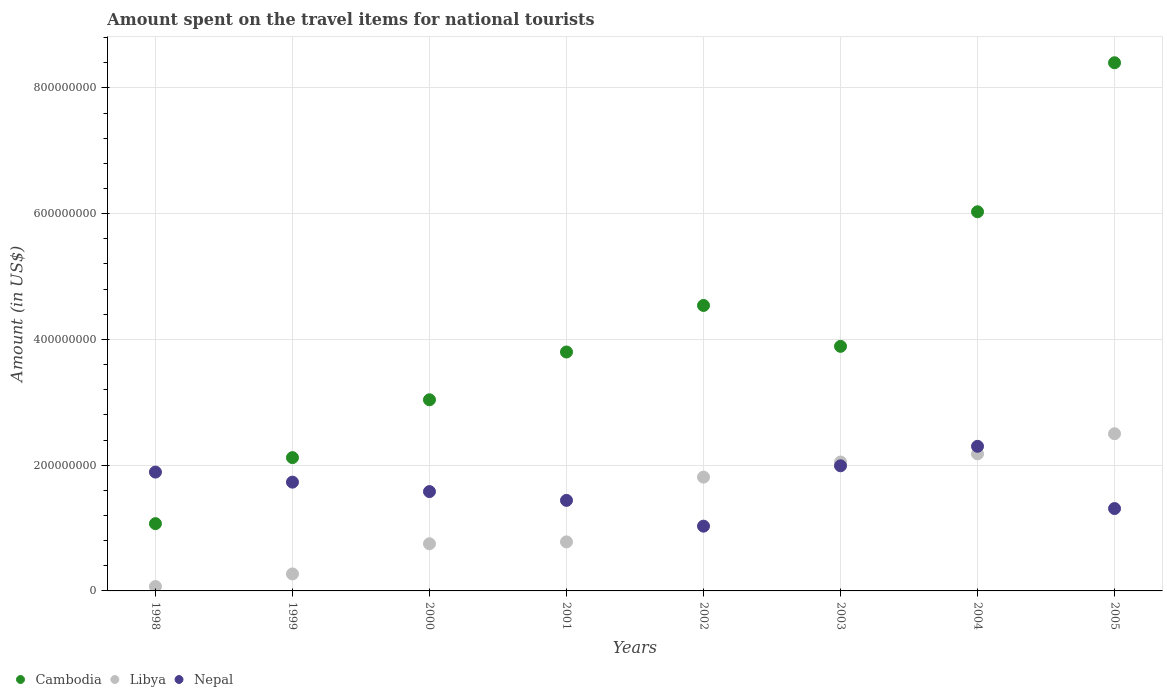What is the amount spent on the travel items for national tourists in Cambodia in 1998?
Your answer should be compact. 1.07e+08. Across all years, what is the maximum amount spent on the travel items for national tourists in Cambodia?
Your answer should be compact. 8.40e+08. Across all years, what is the minimum amount spent on the travel items for national tourists in Cambodia?
Provide a short and direct response. 1.07e+08. In which year was the amount spent on the travel items for national tourists in Nepal minimum?
Make the answer very short. 2002. What is the total amount spent on the travel items for national tourists in Libya in the graph?
Your response must be concise. 1.04e+09. What is the difference between the amount spent on the travel items for national tourists in Libya in 1998 and the amount spent on the travel items for national tourists in Nepal in 1999?
Keep it short and to the point. -1.66e+08. What is the average amount spent on the travel items for national tourists in Nepal per year?
Offer a terse response. 1.66e+08. In the year 1998, what is the difference between the amount spent on the travel items for national tourists in Nepal and amount spent on the travel items for national tourists in Libya?
Your response must be concise. 1.82e+08. What is the ratio of the amount spent on the travel items for national tourists in Libya in 2000 to that in 2003?
Make the answer very short. 0.37. What is the difference between the highest and the second highest amount spent on the travel items for national tourists in Nepal?
Keep it short and to the point. 3.10e+07. What is the difference between the highest and the lowest amount spent on the travel items for national tourists in Nepal?
Offer a very short reply. 1.27e+08. Is the sum of the amount spent on the travel items for national tourists in Libya in 1998 and 2000 greater than the maximum amount spent on the travel items for national tourists in Cambodia across all years?
Give a very brief answer. No. Is the amount spent on the travel items for national tourists in Libya strictly less than the amount spent on the travel items for national tourists in Cambodia over the years?
Keep it short and to the point. Yes. What is the difference between two consecutive major ticks on the Y-axis?
Your answer should be compact. 2.00e+08. Are the values on the major ticks of Y-axis written in scientific E-notation?
Make the answer very short. No. Does the graph contain grids?
Make the answer very short. Yes. Where does the legend appear in the graph?
Your answer should be very brief. Bottom left. What is the title of the graph?
Provide a succinct answer. Amount spent on the travel items for national tourists. What is the label or title of the Y-axis?
Make the answer very short. Amount (in US$). What is the Amount (in US$) of Cambodia in 1998?
Your answer should be compact. 1.07e+08. What is the Amount (in US$) in Nepal in 1998?
Your answer should be compact. 1.89e+08. What is the Amount (in US$) of Cambodia in 1999?
Provide a short and direct response. 2.12e+08. What is the Amount (in US$) of Libya in 1999?
Offer a very short reply. 2.70e+07. What is the Amount (in US$) of Nepal in 1999?
Keep it short and to the point. 1.73e+08. What is the Amount (in US$) of Cambodia in 2000?
Your answer should be very brief. 3.04e+08. What is the Amount (in US$) of Libya in 2000?
Keep it short and to the point. 7.50e+07. What is the Amount (in US$) in Nepal in 2000?
Offer a terse response. 1.58e+08. What is the Amount (in US$) of Cambodia in 2001?
Make the answer very short. 3.80e+08. What is the Amount (in US$) of Libya in 2001?
Provide a succinct answer. 7.80e+07. What is the Amount (in US$) of Nepal in 2001?
Your response must be concise. 1.44e+08. What is the Amount (in US$) of Cambodia in 2002?
Offer a very short reply. 4.54e+08. What is the Amount (in US$) of Libya in 2002?
Ensure brevity in your answer.  1.81e+08. What is the Amount (in US$) of Nepal in 2002?
Provide a short and direct response. 1.03e+08. What is the Amount (in US$) of Cambodia in 2003?
Provide a short and direct response. 3.89e+08. What is the Amount (in US$) in Libya in 2003?
Your answer should be compact. 2.05e+08. What is the Amount (in US$) of Nepal in 2003?
Keep it short and to the point. 1.99e+08. What is the Amount (in US$) in Cambodia in 2004?
Your answer should be very brief. 6.03e+08. What is the Amount (in US$) in Libya in 2004?
Offer a terse response. 2.18e+08. What is the Amount (in US$) in Nepal in 2004?
Make the answer very short. 2.30e+08. What is the Amount (in US$) in Cambodia in 2005?
Offer a terse response. 8.40e+08. What is the Amount (in US$) in Libya in 2005?
Give a very brief answer. 2.50e+08. What is the Amount (in US$) of Nepal in 2005?
Offer a terse response. 1.31e+08. Across all years, what is the maximum Amount (in US$) in Cambodia?
Give a very brief answer. 8.40e+08. Across all years, what is the maximum Amount (in US$) of Libya?
Your answer should be compact. 2.50e+08. Across all years, what is the maximum Amount (in US$) of Nepal?
Make the answer very short. 2.30e+08. Across all years, what is the minimum Amount (in US$) of Cambodia?
Your answer should be compact. 1.07e+08. Across all years, what is the minimum Amount (in US$) in Nepal?
Your answer should be compact. 1.03e+08. What is the total Amount (in US$) of Cambodia in the graph?
Provide a short and direct response. 3.29e+09. What is the total Amount (in US$) of Libya in the graph?
Provide a succinct answer. 1.04e+09. What is the total Amount (in US$) in Nepal in the graph?
Your answer should be compact. 1.33e+09. What is the difference between the Amount (in US$) in Cambodia in 1998 and that in 1999?
Provide a succinct answer. -1.05e+08. What is the difference between the Amount (in US$) in Libya in 1998 and that in 1999?
Offer a terse response. -2.00e+07. What is the difference between the Amount (in US$) in Nepal in 1998 and that in 1999?
Your answer should be compact. 1.60e+07. What is the difference between the Amount (in US$) of Cambodia in 1998 and that in 2000?
Offer a terse response. -1.97e+08. What is the difference between the Amount (in US$) of Libya in 1998 and that in 2000?
Provide a succinct answer. -6.80e+07. What is the difference between the Amount (in US$) of Nepal in 1998 and that in 2000?
Make the answer very short. 3.10e+07. What is the difference between the Amount (in US$) in Cambodia in 1998 and that in 2001?
Your answer should be very brief. -2.73e+08. What is the difference between the Amount (in US$) in Libya in 1998 and that in 2001?
Your response must be concise. -7.10e+07. What is the difference between the Amount (in US$) in Nepal in 1998 and that in 2001?
Offer a terse response. 4.50e+07. What is the difference between the Amount (in US$) in Cambodia in 1998 and that in 2002?
Ensure brevity in your answer.  -3.47e+08. What is the difference between the Amount (in US$) of Libya in 1998 and that in 2002?
Provide a succinct answer. -1.74e+08. What is the difference between the Amount (in US$) of Nepal in 1998 and that in 2002?
Give a very brief answer. 8.60e+07. What is the difference between the Amount (in US$) in Cambodia in 1998 and that in 2003?
Ensure brevity in your answer.  -2.82e+08. What is the difference between the Amount (in US$) of Libya in 1998 and that in 2003?
Keep it short and to the point. -1.98e+08. What is the difference between the Amount (in US$) of Nepal in 1998 and that in 2003?
Your response must be concise. -1.00e+07. What is the difference between the Amount (in US$) of Cambodia in 1998 and that in 2004?
Your answer should be very brief. -4.96e+08. What is the difference between the Amount (in US$) of Libya in 1998 and that in 2004?
Provide a short and direct response. -2.11e+08. What is the difference between the Amount (in US$) in Nepal in 1998 and that in 2004?
Ensure brevity in your answer.  -4.10e+07. What is the difference between the Amount (in US$) of Cambodia in 1998 and that in 2005?
Your answer should be compact. -7.33e+08. What is the difference between the Amount (in US$) of Libya in 1998 and that in 2005?
Offer a very short reply. -2.43e+08. What is the difference between the Amount (in US$) in Nepal in 1998 and that in 2005?
Ensure brevity in your answer.  5.80e+07. What is the difference between the Amount (in US$) of Cambodia in 1999 and that in 2000?
Offer a terse response. -9.20e+07. What is the difference between the Amount (in US$) in Libya in 1999 and that in 2000?
Provide a short and direct response. -4.80e+07. What is the difference between the Amount (in US$) of Nepal in 1999 and that in 2000?
Your response must be concise. 1.50e+07. What is the difference between the Amount (in US$) in Cambodia in 1999 and that in 2001?
Provide a succinct answer. -1.68e+08. What is the difference between the Amount (in US$) of Libya in 1999 and that in 2001?
Keep it short and to the point. -5.10e+07. What is the difference between the Amount (in US$) in Nepal in 1999 and that in 2001?
Your answer should be compact. 2.90e+07. What is the difference between the Amount (in US$) in Cambodia in 1999 and that in 2002?
Make the answer very short. -2.42e+08. What is the difference between the Amount (in US$) in Libya in 1999 and that in 2002?
Your answer should be compact. -1.54e+08. What is the difference between the Amount (in US$) of Nepal in 1999 and that in 2002?
Offer a terse response. 7.00e+07. What is the difference between the Amount (in US$) in Cambodia in 1999 and that in 2003?
Provide a short and direct response. -1.77e+08. What is the difference between the Amount (in US$) of Libya in 1999 and that in 2003?
Offer a very short reply. -1.78e+08. What is the difference between the Amount (in US$) in Nepal in 1999 and that in 2003?
Your answer should be very brief. -2.60e+07. What is the difference between the Amount (in US$) of Cambodia in 1999 and that in 2004?
Your answer should be compact. -3.91e+08. What is the difference between the Amount (in US$) in Libya in 1999 and that in 2004?
Offer a terse response. -1.91e+08. What is the difference between the Amount (in US$) in Nepal in 1999 and that in 2004?
Keep it short and to the point. -5.70e+07. What is the difference between the Amount (in US$) in Cambodia in 1999 and that in 2005?
Provide a succinct answer. -6.28e+08. What is the difference between the Amount (in US$) in Libya in 1999 and that in 2005?
Keep it short and to the point. -2.23e+08. What is the difference between the Amount (in US$) in Nepal in 1999 and that in 2005?
Offer a terse response. 4.20e+07. What is the difference between the Amount (in US$) of Cambodia in 2000 and that in 2001?
Your answer should be very brief. -7.60e+07. What is the difference between the Amount (in US$) of Libya in 2000 and that in 2001?
Offer a terse response. -3.00e+06. What is the difference between the Amount (in US$) of Nepal in 2000 and that in 2001?
Your response must be concise. 1.40e+07. What is the difference between the Amount (in US$) in Cambodia in 2000 and that in 2002?
Make the answer very short. -1.50e+08. What is the difference between the Amount (in US$) in Libya in 2000 and that in 2002?
Your response must be concise. -1.06e+08. What is the difference between the Amount (in US$) in Nepal in 2000 and that in 2002?
Your answer should be compact. 5.50e+07. What is the difference between the Amount (in US$) in Cambodia in 2000 and that in 2003?
Keep it short and to the point. -8.50e+07. What is the difference between the Amount (in US$) in Libya in 2000 and that in 2003?
Give a very brief answer. -1.30e+08. What is the difference between the Amount (in US$) in Nepal in 2000 and that in 2003?
Your response must be concise. -4.10e+07. What is the difference between the Amount (in US$) in Cambodia in 2000 and that in 2004?
Ensure brevity in your answer.  -2.99e+08. What is the difference between the Amount (in US$) of Libya in 2000 and that in 2004?
Offer a terse response. -1.43e+08. What is the difference between the Amount (in US$) of Nepal in 2000 and that in 2004?
Give a very brief answer. -7.20e+07. What is the difference between the Amount (in US$) of Cambodia in 2000 and that in 2005?
Make the answer very short. -5.36e+08. What is the difference between the Amount (in US$) of Libya in 2000 and that in 2005?
Your answer should be very brief. -1.75e+08. What is the difference between the Amount (in US$) in Nepal in 2000 and that in 2005?
Your response must be concise. 2.70e+07. What is the difference between the Amount (in US$) of Cambodia in 2001 and that in 2002?
Offer a terse response. -7.40e+07. What is the difference between the Amount (in US$) in Libya in 2001 and that in 2002?
Provide a succinct answer. -1.03e+08. What is the difference between the Amount (in US$) in Nepal in 2001 and that in 2002?
Your answer should be compact. 4.10e+07. What is the difference between the Amount (in US$) in Cambodia in 2001 and that in 2003?
Give a very brief answer. -9.00e+06. What is the difference between the Amount (in US$) of Libya in 2001 and that in 2003?
Provide a short and direct response. -1.27e+08. What is the difference between the Amount (in US$) in Nepal in 2001 and that in 2003?
Provide a succinct answer. -5.50e+07. What is the difference between the Amount (in US$) of Cambodia in 2001 and that in 2004?
Offer a terse response. -2.23e+08. What is the difference between the Amount (in US$) in Libya in 2001 and that in 2004?
Make the answer very short. -1.40e+08. What is the difference between the Amount (in US$) of Nepal in 2001 and that in 2004?
Your response must be concise. -8.60e+07. What is the difference between the Amount (in US$) of Cambodia in 2001 and that in 2005?
Your answer should be compact. -4.60e+08. What is the difference between the Amount (in US$) in Libya in 2001 and that in 2005?
Your answer should be compact. -1.72e+08. What is the difference between the Amount (in US$) of Nepal in 2001 and that in 2005?
Offer a very short reply. 1.30e+07. What is the difference between the Amount (in US$) of Cambodia in 2002 and that in 2003?
Offer a very short reply. 6.50e+07. What is the difference between the Amount (in US$) in Libya in 2002 and that in 2003?
Keep it short and to the point. -2.40e+07. What is the difference between the Amount (in US$) in Nepal in 2002 and that in 2003?
Ensure brevity in your answer.  -9.60e+07. What is the difference between the Amount (in US$) in Cambodia in 2002 and that in 2004?
Offer a very short reply. -1.49e+08. What is the difference between the Amount (in US$) in Libya in 2002 and that in 2004?
Your answer should be compact. -3.70e+07. What is the difference between the Amount (in US$) of Nepal in 2002 and that in 2004?
Keep it short and to the point. -1.27e+08. What is the difference between the Amount (in US$) of Cambodia in 2002 and that in 2005?
Make the answer very short. -3.86e+08. What is the difference between the Amount (in US$) in Libya in 2002 and that in 2005?
Keep it short and to the point. -6.90e+07. What is the difference between the Amount (in US$) in Nepal in 2002 and that in 2005?
Offer a very short reply. -2.80e+07. What is the difference between the Amount (in US$) of Cambodia in 2003 and that in 2004?
Give a very brief answer. -2.14e+08. What is the difference between the Amount (in US$) of Libya in 2003 and that in 2004?
Keep it short and to the point. -1.30e+07. What is the difference between the Amount (in US$) in Nepal in 2003 and that in 2004?
Make the answer very short. -3.10e+07. What is the difference between the Amount (in US$) in Cambodia in 2003 and that in 2005?
Keep it short and to the point. -4.51e+08. What is the difference between the Amount (in US$) in Libya in 2003 and that in 2005?
Provide a succinct answer. -4.50e+07. What is the difference between the Amount (in US$) in Nepal in 2003 and that in 2005?
Your answer should be very brief. 6.80e+07. What is the difference between the Amount (in US$) of Cambodia in 2004 and that in 2005?
Offer a very short reply. -2.37e+08. What is the difference between the Amount (in US$) in Libya in 2004 and that in 2005?
Provide a short and direct response. -3.20e+07. What is the difference between the Amount (in US$) of Nepal in 2004 and that in 2005?
Provide a short and direct response. 9.90e+07. What is the difference between the Amount (in US$) of Cambodia in 1998 and the Amount (in US$) of Libya in 1999?
Keep it short and to the point. 8.00e+07. What is the difference between the Amount (in US$) of Cambodia in 1998 and the Amount (in US$) of Nepal in 1999?
Offer a very short reply. -6.60e+07. What is the difference between the Amount (in US$) of Libya in 1998 and the Amount (in US$) of Nepal in 1999?
Offer a terse response. -1.66e+08. What is the difference between the Amount (in US$) in Cambodia in 1998 and the Amount (in US$) in Libya in 2000?
Provide a succinct answer. 3.20e+07. What is the difference between the Amount (in US$) in Cambodia in 1998 and the Amount (in US$) in Nepal in 2000?
Provide a succinct answer. -5.10e+07. What is the difference between the Amount (in US$) of Libya in 1998 and the Amount (in US$) of Nepal in 2000?
Offer a terse response. -1.51e+08. What is the difference between the Amount (in US$) in Cambodia in 1998 and the Amount (in US$) in Libya in 2001?
Your answer should be compact. 2.90e+07. What is the difference between the Amount (in US$) in Cambodia in 1998 and the Amount (in US$) in Nepal in 2001?
Provide a short and direct response. -3.70e+07. What is the difference between the Amount (in US$) in Libya in 1998 and the Amount (in US$) in Nepal in 2001?
Your answer should be compact. -1.37e+08. What is the difference between the Amount (in US$) in Cambodia in 1998 and the Amount (in US$) in Libya in 2002?
Ensure brevity in your answer.  -7.40e+07. What is the difference between the Amount (in US$) in Libya in 1998 and the Amount (in US$) in Nepal in 2002?
Your response must be concise. -9.60e+07. What is the difference between the Amount (in US$) of Cambodia in 1998 and the Amount (in US$) of Libya in 2003?
Ensure brevity in your answer.  -9.80e+07. What is the difference between the Amount (in US$) of Cambodia in 1998 and the Amount (in US$) of Nepal in 2003?
Give a very brief answer. -9.20e+07. What is the difference between the Amount (in US$) of Libya in 1998 and the Amount (in US$) of Nepal in 2003?
Make the answer very short. -1.92e+08. What is the difference between the Amount (in US$) in Cambodia in 1998 and the Amount (in US$) in Libya in 2004?
Provide a succinct answer. -1.11e+08. What is the difference between the Amount (in US$) in Cambodia in 1998 and the Amount (in US$) in Nepal in 2004?
Ensure brevity in your answer.  -1.23e+08. What is the difference between the Amount (in US$) in Libya in 1998 and the Amount (in US$) in Nepal in 2004?
Offer a terse response. -2.23e+08. What is the difference between the Amount (in US$) in Cambodia in 1998 and the Amount (in US$) in Libya in 2005?
Provide a short and direct response. -1.43e+08. What is the difference between the Amount (in US$) of Cambodia in 1998 and the Amount (in US$) of Nepal in 2005?
Make the answer very short. -2.40e+07. What is the difference between the Amount (in US$) of Libya in 1998 and the Amount (in US$) of Nepal in 2005?
Offer a terse response. -1.24e+08. What is the difference between the Amount (in US$) in Cambodia in 1999 and the Amount (in US$) in Libya in 2000?
Offer a very short reply. 1.37e+08. What is the difference between the Amount (in US$) in Cambodia in 1999 and the Amount (in US$) in Nepal in 2000?
Offer a terse response. 5.40e+07. What is the difference between the Amount (in US$) in Libya in 1999 and the Amount (in US$) in Nepal in 2000?
Give a very brief answer. -1.31e+08. What is the difference between the Amount (in US$) in Cambodia in 1999 and the Amount (in US$) in Libya in 2001?
Provide a succinct answer. 1.34e+08. What is the difference between the Amount (in US$) of Cambodia in 1999 and the Amount (in US$) of Nepal in 2001?
Your response must be concise. 6.80e+07. What is the difference between the Amount (in US$) in Libya in 1999 and the Amount (in US$) in Nepal in 2001?
Offer a very short reply. -1.17e+08. What is the difference between the Amount (in US$) of Cambodia in 1999 and the Amount (in US$) of Libya in 2002?
Make the answer very short. 3.10e+07. What is the difference between the Amount (in US$) in Cambodia in 1999 and the Amount (in US$) in Nepal in 2002?
Your answer should be compact. 1.09e+08. What is the difference between the Amount (in US$) of Libya in 1999 and the Amount (in US$) of Nepal in 2002?
Keep it short and to the point. -7.60e+07. What is the difference between the Amount (in US$) of Cambodia in 1999 and the Amount (in US$) of Nepal in 2003?
Offer a terse response. 1.30e+07. What is the difference between the Amount (in US$) in Libya in 1999 and the Amount (in US$) in Nepal in 2003?
Keep it short and to the point. -1.72e+08. What is the difference between the Amount (in US$) in Cambodia in 1999 and the Amount (in US$) in Libya in 2004?
Provide a short and direct response. -6.00e+06. What is the difference between the Amount (in US$) in Cambodia in 1999 and the Amount (in US$) in Nepal in 2004?
Give a very brief answer. -1.80e+07. What is the difference between the Amount (in US$) in Libya in 1999 and the Amount (in US$) in Nepal in 2004?
Make the answer very short. -2.03e+08. What is the difference between the Amount (in US$) in Cambodia in 1999 and the Amount (in US$) in Libya in 2005?
Your answer should be very brief. -3.80e+07. What is the difference between the Amount (in US$) in Cambodia in 1999 and the Amount (in US$) in Nepal in 2005?
Provide a short and direct response. 8.10e+07. What is the difference between the Amount (in US$) in Libya in 1999 and the Amount (in US$) in Nepal in 2005?
Your answer should be very brief. -1.04e+08. What is the difference between the Amount (in US$) of Cambodia in 2000 and the Amount (in US$) of Libya in 2001?
Make the answer very short. 2.26e+08. What is the difference between the Amount (in US$) in Cambodia in 2000 and the Amount (in US$) in Nepal in 2001?
Provide a succinct answer. 1.60e+08. What is the difference between the Amount (in US$) of Libya in 2000 and the Amount (in US$) of Nepal in 2001?
Ensure brevity in your answer.  -6.90e+07. What is the difference between the Amount (in US$) in Cambodia in 2000 and the Amount (in US$) in Libya in 2002?
Your answer should be compact. 1.23e+08. What is the difference between the Amount (in US$) in Cambodia in 2000 and the Amount (in US$) in Nepal in 2002?
Your answer should be very brief. 2.01e+08. What is the difference between the Amount (in US$) of Libya in 2000 and the Amount (in US$) of Nepal in 2002?
Make the answer very short. -2.80e+07. What is the difference between the Amount (in US$) in Cambodia in 2000 and the Amount (in US$) in Libya in 2003?
Your answer should be very brief. 9.90e+07. What is the difference between the Amount (in US$) of Cambodia in 2000 and the Amount (in US$) of Nepal in 2003?
Your response must be concise. 1.05e+08. What is the difference between the Amount (in US$) in Libya in 2000 and the Amount (in US$) in Nepal in 2003?
Offer a very short reply. -1.24e+08. What is the difference between the Amount (in US$) of Cambodia in 2000 and the Amount (in US$) of Libya in 2004?
Your answer should be compact. 8.60e+07. What is the difference between the Amount (in US$) in Cambodia in 2000 and the Amount (in US$) in Nepal in 2004?
Your answer should be very brief. 7.40e+07. What is the difference between the Amount (in US$) in Libya in 2000 and the Amount (in US$) in Nepal in 2004?
Your response must be concise. -1.55e+08. What is the difference between the Amount (in US$) of Cambodia in 2000 and the Amount (in US$) of Libya in 2005?
Give a very brief answer. 5.40e+07. What is the difference between the Amount (in US$) in Cambodia in 2000 and the Amount (in US$) in Nepal in 2005?
Make the answer very short. 1.73e+08. What is the difference between the Amount (in US$) in Libya in 2000 and the Amount (in US$) in Nepal in 2005?
Provide a succinct answer. -5.60e+07. What is the difference between the Amount (in US$) of Cambodia in 2001 and the Amount (in US$) of Libya in 2002?
Provide a succinct answer. 1.99e+08. What is the difference between the Amount (in US$) in Cambodia in 2001 and the Amount (in US$) in Nepal in 2002?
Provide a succinct answer. 2.77e+08. What is the difference between the Amount (in US$) of Libya in 2001 and the Amount (in US$) of Nepal in 2002?
Provide a succinct answer. -2.50e+07. What is the difference between the Amount (in US$) in Cambodia in 2001 and the Amount (in US$) in Libya in 2003?
Offer a very short reply. 1.75e+08. What is the difference between the Amount (in US$) of Cambodia in 2001 and the Amount (in US$) of Nepal in 2003?
Provide a succinct answer. 1.81e+08. What is the difference between the Amount (in US$) in Libya in 2001 and the Amount (in US$) in Nepal in 2003?
Ensure brevity in your answer.  -1.21e+08. What is the difference between the Amount (in US$) of Cambodia in 2001 and the Amount (in US$) of Libya in 2004?
Ensure brevity in your answer.  1.62e+08. What is the difference between the Amount (in US$) of Cambodia in 2001 and the Amount (in US$) of Nepal in 2004?
Offer a very short reply. 1.50e+08. What is the difference between the Amount (in US$) in Libya in 2001 and the Amount (in US$) in Nepal in 2004?
Provide a short and direct response. -1.52e+08. What is the difference between the Amount (in US$) in Cambodia in 2001 and the Amount (in US$) in Libya in 2005?
Ensure brevity in your answer.  1.30e+08. What is the difference between the Amount (in US$) in Cambodia in 2001 and the Amount (in US$) in Nepal in 2005?
Your answer should be very brief. 2.49e+08. What is the difference between the Amount (in US$) in Libya in 2001 and the Amount (in US$) in Nepal in 2005?
Make the answer very short. -5.30e+07. What is the difference between the Amount (in US$) of Cambodia in 2002 and the Amount (in US$) of Libya in 2003?
Offer a very short reply. 2.49e+08. What is the difference between the Amount (in US$) in Cambodia in 2002 and the Amount (in US$) in Nepal in 2003?
Give a very brief answer. 2.55e+08. What is the difference between the Amount (in US$) of Libya in 2002 and the Amount (in US$) of Nepal in 2003?
Your answer should be compact. -1.80e+07. What is the difference between the Amount (in US$) in Cambodia in 2002 and the Amount (in US$) in Libya in 2004?
Ensure brevity in your answer.  2.36e+08. What is the difference between the Amount (in US$) of Cambodia in 2002 and the Amount (in US$) of Nepal in 2004?
Your response must be concise. 2.24e+08. What is the difference between the Amount (in US$) of Libya in 2002 and the Amount (in US$) of Nepal in 2004?
Offer a terse response. -4.90e+07. What is the difference between the Amount (in US$) in Cambodia in 2002 and the Amount (in US$) in Libya in 2005?
Your response must be concise. 2.04e+08. What is the difference between the Amount (in US$) of Cambodia in 2002 and the Amount (in US$) of Nepal in 2005?
Offer a very short reply. 3.23e+08. What is the difference between the Amount (in US$) in Cambodia in 2003 and the Amount (in US$) in Libya in 2004?
Offer a very short reply. 1.71e+08. What is the difference between the Amount (in US$) in Cambodia in 2003 and the Amount (in US$) in Nepal in 2004?
Offer a terse response. 1.59e+08. What is the difference between the Amount (in US$) in Libya in 2003 and the Amount (in US$) in Nepal in 2004?
Your response must be concise. -2.50e+07. What is the difference between the Amount (in US$) of Cambodia in 2003 and the Amount (in US$) of Libya in 2005?
Make the answer very short. 1.39e+08. What is the difference between the Amount (in US$) of Cambodia in 2003 and the Amount (in US$) of Nepal in 2005?
Ensure brevity in your answer.  2.58e+08. What is the difference between the Amount (in US$) of Libya in 2003 and the Amount (in US$) of Nepal in 2005?
Give a very brief answer. 7.40e+07. What is the difference between the Amount (in US$) in Cambodia in 2004 and the Amount (in US$) in Libya in 2005?
Your answer should be very brief. 3.53e+08. What is the difference between the Amount (in US$) of Cambodia in 2004 and the Amount (in US$) of Nepal in 2005?
Your answer should be very brief. 4.72e+08. What is the difference between the Amount (in US$) in Libya in 2004 and the Amount (in US$) in Nepal in 2005?
Provide a succinct answer. 8.70e+07. What is the average Amount (in US$) in Cambodia per year?
Your response must be concise. 4.11e+08. What is the average Amount (in US$) of Libya per year?
Give a very brief answer. 1.30e+08. What is the average Amount (in US$) of Nepal per year?
Your answer should be very brief. 1.66e+08. In the year 1998, what is the difference between the Amount (in US$) in Cambodia and Amount (in US$) in Libya?
Ensure brevity in your answer.  1.00e+08. In the year 1998, what is the difference between the Amount (in US$) of Cambodia and Amount (in US$) of Nepal?
Make the answer very short. -8.20e+07. In the year 1998, what is the difference between the Amount (in US$) of Libya and Amount (in US$) of Nepal?
Offer a very short reply. -1.82e+08. In the year 1999, what is the difference between the Amount (in US$) in Cambodia and Amount (in US$) in Libya?
Keep it short and to the point. 1.85e+08. In the year 1999, what is the difference between the Amount (in US$) of Cambodia and Amount (in US$) of Nepal?
Provide a succinct answer. 3.90e+07. In the year 1999, what is the difference between the Amount (in US$) of Libya and Amount (in US$) of Nepal?
Make the answer very short. -1.46e+08. In the year 2000, what is the difference between the Amount (in US$) of Cambodia and Amount (in US$) of Libya?
Offer a very short reply. 2.29e+08. In the year 2000, what is the difference between the Amount (in US$) of Cambodia and Amount (in US$) of Nepal?
Give a very brief answer. 1.46e+08. In the year 2000, what is the difference between the Amount (in US$) in Libya and Amount (in US$) in Nepal?
Make the answer very short. -8.30e+07. In the year 2001, what is the difference between the Amount (in US$) of Cambodia and Amount (in US$) of Libya?
Your response must be concise. 3.02e+08. In the year 2001, what is the difference between the Amount (in US$) in Cambodia and Amount (in US$) in Nepal?
Provide a short and direct response. 2.36e+08. In the year 2001, what is the difference between the Amount (in US$) of Libya and Amount (in US$) of Nepal?
Offer a terse response. -6.60e+07. In the year 2002, what is the difference between the Amount (in US$) of Cambodia and Amount (in US$) of Libya?
Make the answer very short. 2.73e+08. In the year 2002, what is the difference between the Amount (in US$) of Cambodia and Amount (in US$) of Nepal?
Ensure brevity in your answer.  3.51e+08. In the year 2002, what is the difference between the Amount (in US$) of Libya and Amount (in US$) of Nepal?
Provide a succinct answer. 7.80e+07. In the year 2003, what is the difference between the Amount (in US$) of Cambodia and Amount (in US$) of Libya?
Your answer should be compact. 1.84e+08. In the year 2003, what is the difference between the Amount (in US$) of Cambodia and Amount (in US$) of Nepal?
Ensure brevity in your answer.  1.90e+08. In the year 2003, what is the difference between the Amount (in US$) in Libya and Amount (in US$) in Nepal?
Give a very brief answer. 6.00e+06. In the year 2004, what is the difference between the Amount (in US$) of Cambodia and Amount (in US$) of Libya?
Ensure brevity in your answer.  3.85e+08. In the year 2004, what is the difference between the Amount (in US$) of Cambodia and Amount (in US$) of Nepal?
Provide a short and direct response. 3.73e+08. In the year 2004, what is the difference between the Amount (in US$) of Libya and Amount (in US$) of Nepal?
Your answer should be very brief. -1.20e+07. In the year 2005, what is the difference between the Amount (in US$) of Cambodia and Amount (in US$) of Libya?
Your answer should be compact. 5.90e+08. In the year 2005, what is the difference between the Amount (in US$) in Cambodia and Amount (in US$) in Nepal?
Keep it short and to the point. 7.09e+08. In the year 2005, what is the difference between the Amount (in US$) of Libya and Amount (in US$) of Nepal?
Offer a very short reply. 1.19e+08. What is the ratio of the Amount (in US$) in Cambodia in 1998 to that in 1999?
Offer a very short reply. 0.5. What is the ratio of the Amount (in US$) of Libya in 1998 to that in 1999?
Your answer should be compact. 0.26. What is the ratio of the Amount (in US$) in Nepal in 1998 to that in 1999?
Give a very brief answer. 1.09. What is the ratio of the Amount (in US$) of Cambodia in 1998 to that in 2000?
Provide a short and direct response. 0.35. What is the ratio of the Amount (in US$) of Libya in 1998 to that in 2000?
Ensure brevity in your answer.  0.09. What is the ratio of the Amount (in US$) of Nepal in 1998 to that in 2000?
Your response must be concise. 1.2. What is the ratio of the Amount (in US$) of Cambodia in 1998 to that in 2001?
Your answer should be very brief. 0.28. What is the ratio of the Amount (in US$) of Libya in 1998 to that in 2001?
Your answer should be compact. 0.09. What is the ratio of the Amount (in US$) in Nepal in 1998 to that in 2001?
Ensure brevity in your answer.  1.31. What is the ratio of the Amount (in US$) in Cambodia in 1998 to that in 2002?
Your answer should be compact. 0.24. What is the ratio of the Amount (in US$) of Libya in 1998 to that in 2002?
Give a very brief answer. 0.04. What is the ratio of the Amount (in US$) of Nepal in 1998 to that in 2002?
Offer a terse response. 1.83. What is the ratio of the Amount (in US$) of Cambodia in 1998 to that in 2003?
Provide a short and direct response. 0.28. What is the ratio of the Amount (in US$) in Libya in 1998 to that in 2003?
Your answer should be compact. 0.03. What is the ratio of the Amount (in US$) of Nepal in 1998 to that in 2003?
Ensure brevity in your answer.  0.95. What is the ratio of the Amount (in US$) of Cambodia in 1998 to that in 2004?
Make the answer very short. 0.18. What is the ratio of the Amount (in US$) of Libya in 1998 to that in 2004?
Make the answer very short. 0.03. What is the ratio of the Amount (in US$) in Nepal in 1998 to that in 2004?
Ensure brevity in your answer.  0.82. What is the ratio of the Amount (in US$) in Cambodia in 1998 to that in 2005?
Make the answer very short. 0.13. What is the ratio of the Amount (in US$) of Libya in 1998 to that in 2005?
Make the answer very short. 0.03. What is the ratio of the Amount (in US$) in Nepal in 1998 to that in 2005?
Make the answer very short. 1.44. What is the ratio of the Amount (in US$) of Cambodia in 1999 to that in 2000?
Provide a short and direct response. 0.7. What is the ratio of the Amount (in US$) of Libya in 1999 to that in 2000?
Your response must be concise. 0.36. What is the ratio of the Amount (in US$) in Nepal in 1999 to that in 2000?
Your answer should be compact. 1.09. What is the ratio of the Amount (in US$) in Cambodia in 1999 to that in 2001?
Provide a short and direct response. 0.56. What is the ratio of the Amount (in US$) of Libya in 1999 to that in 2001?
Offer a terse response. 0.35. What is the ratio of the Amount (in US$) of Nepal in 1999 to that in 2001?
Give a very brief answer. 1.2. What is the ratio of the Amount (in US$) in Cambodia in 1999 to that in 2002?
Offer a very short reply. 0.47. What is the ratio of the Amount (in US$) of Libya in 1999 to that in 2002?
Offer a very short reply. 0.15. What is the ratio of the Amount (in US$) of Nepal in 1999 to that in 2002?
Keep it short and to the point. 1.68. What is the ratio of the Amount (in US$) in Cambodia in 1999 to that in 2003?
Give a very brief answer. 0.55. What is the ratio of the Amount (in US$) in Libya in 1999 to that in 2003?
Provide a short and direct response. 0.13. What is the ratio of the Amount (in US$) in Nepal in 1999 to that in 2003?
Provide a short and direct response. 0.87. What is the ratio of the Amount (in US$) in Cambodia in 1999 to that in 2004?
Provide a succinct answer. 0.35. What is the ratio of the Amount (in US$) of Libya in 1999 to that in 2004?
Offer a terse response. 0.12. What is the ratio of the Amount (in US$) in Nepal in 1999 to that in 2004?
Keep it short and to the point. 0.75. What is the ratio of the Amount (in US$) of Cambodia in 1999 to that in 2005?
Provide a succinct answer. 0.25. What is the ratio of the Amount (in US$) of Libya in 1999 to that in 2005?
Give a very brief answer. 0.11. What is the ratio of the Amount (in US$) in Nepal in 1999 to that in 2005?
Offer a terse response. 1.32. What is the ratio of the Amount (in US$) of Cambodia in 2000 to that in 2001?
Offer a very short reply. 0.8. What is the ratio of the Amount (in US$) in Libya in 2000 to that in 2001?
Make the answer very short. 0.96. What is the ratio of the Amount (in US$) in Nepal in 2000 to that in 2001?
Make the answer very short. 1.1. What is the ratio of the Amount (in US$) of Cambodia in 2000 to that in 2002?
Make the answer very short. 0.67. What is the ratio of the Amount (in US$) of Libya in 2000 to that in 2002?
Make the answer very short. 0.41. What is the ratio of the Amount (in US$) in Nepal in 2000 to that in 2002?
Offer a very short reply. 1.53. What is the ratio of the Amount (in US$) of Cambodia in 2000 to that in 2003?
Offer a very short reply. 0.78. What is the ratio of the Amount (in US$) in Libya in 2000 to that in 2003?
Ensure brevity in your answer.  0.37. What is the ratio of the Amount (in US$) of Nepal in 2000 to that in 2003?
Make the answer very short. 0.79. What is the ratio of the Amount (in US$) in Cambodia in 2000 to that in 2004?
Keep it short and to the point. 0.5. What is the ratio of the Amount (in US$) of Libya in 2000 to that in 2004?
Give a very brief answer. 0.34. What is the ratio of the Amount (in US$) in Nepal in 2000 to that in 2004?
Your response must be concise. 0.69. What is the ratio of the Amount (in US$) of Cambodia in 2000 to that in 2005?
Your answer should be compact. 0.36. What is the ratio of the Amount (in US$) of Libya in 2000 to that in 2005?
Offer a terse response. 0.3. What is the ratio of the Amount (in US$) in Nepal in 2000 to that in 2005?
Offer a very short reply. 1.21. What is the ratio of the Amount (in US$) of Cambodia in 2001 to that in 2002?
Your answer should be very brief. 0.84. What is the ratio of the Amount (in US$) in Libya in 2001 to that in 2002?
Your answer should be very brief. 0.43. What is the ratio of the Amount (in US$) in Nepal in 2001 to that in 2002?
Offer a terse response. 1.4. What is the ratio of the Amount (in US$) of Cambodia in 2001 to that in 2003?
Your answer should be very brief. 0.98. What is the ratio of the Amount (in US$) of Libya in 2001 to that in 2003?
Your answer should be compact. 0.38. What is the ratio of the Amount (in US$) of Nepal in 2001 to that in 2003?
Keep it short and to the point. 0.72. What is the ratio of the Amount (in US$) in Cambodia in 2001 to that in 2004?
Ensure brevity in your answer.  0.63. What is the ratio of the Amount (in US$) of Libya in 2001 to that in 2004?
Keep it short and to the point. 0.36. What is the ratio of the Amount (in US$) of Nepal in 2001 to that in 2004?
Make the answer very short. 0.63. What is the ratio of the Amount (in US$) of Cambodia in 2001 to that in 2005?
Your answer should be very brief. 0.45. What is the ratio of the Amount (in US$) of Libya in 2001 to that in 2005?
Your answer should be compact. 0.31. What is the ratio of the Amount (in US$) in Nepal in 2001 to that in 2005?
Offer a very short reply. 1.1. What is the ratio of the Amount (in US$) of Cambodia in 2002 to that in 2003?
Your answer should be compact. 1.17. What is the ratio of the Amount (in US$) of Libya in 2002 to that in 2003?
Provide a short and direct response. 0.88. What is the ratio of the Amount (in US$) of Nepal in 2002 to that in 2003?
Your response must be concise. 0.52. What is the ratio of the Amount (in US$) of Cambodia in 2002 to that in 2004?
Provide a short and direct response. 0.75. What is the ratio of the Amount (in US$) in Libya in 2002 to that in 2004?
Ensure brevity in your answer.  0.83. What is the ratio of the Amount (in US$) of Nepal in 2002 to that in 2004?
Ensure brevity in your answer.  0.45. What is the ratio of the Amount (in US$) in Cambodia in 2002 to that in 2005?
Provide a short and direct response. 0.54. What is the ratio of the Amount (in US$) of Libya in 2002 to that in 2005?
Your response must be concise. 0.72. What is the ratio of the Amount (in US$) of Nepal in 2002 to that in 2005?
Your answer should be compact. 0.79. What is the ratio of the Amount (in US$) of Cambodia in 2003 to that in 2004?
Your answer should be very brief. 0.65. What is the ratio of the Amount (in US$) in Libya in 2003 to that in 2004?
Give a very brief answer. 0.94. What is the ratio of the Amount (in US$) in Nepal in 2003 to that in 2004?
Ensure brevity in your answer.  0.87. What is the ratio of the Amount (in US$) of Cambodia in 2003 to that in 2005?
Your answer should be compact. 0.46. What is the ratio of the Amount (in US$) of Libya in 2003 to that in 2005?
Offer a very short reply. 0.82. What is the ratio of the Amount (in US$) in Nepal in 2003 to that in 2005?
Your response must be concise. 1.52. What is the ratio of the Amount (in US$) of Cambodia in 2004 to that in 2005?
Your response must be concise. 0.72. What is the ratio of the Amount (in US$) of Libya in 2004 to that in 2005?
Provide a succinct answer. 0.87. What is the ratio of the Amount (in US$) in Nepal in 2004 to that in 2005?
Provide a short and direct response. 1.76. What is the difference between the highest and the second highest Amount (in US$) in Cambodia?
Offer a very short reply. 2.37e+08. What is the difference between the highest and the second highest Amount (in US$) in Libya?
Your response must be concise. 3.20e+07. What is the difference between the highest and the second highest Amount (in US$) in Nepal?
Your response must be concise. 3.10e+07. What is the difference between the highest and the lowest Amount (in US$) in Cambodia?
Offer a terse response. 7.33e+08. What is the difference between the highest and the lowest Amount (in US$) of Libya?
Make the answer very short. 2.43e+08. What is the difference between the highest and the lowest Amount (in US$) in Nepal?
Make the answer very short. 1.27e+08. 